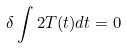<formula> <loc_0><loc_0><loc_500><loc_500>\delta \int 2 T ( t ) d t = 0</formula> 